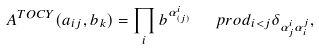<formula> <loc_0><loc_0><loc_500><loc_500>A ^ { T O C Y } ( a _ { i j } , b _ { k } ) = \prod _ { i } b ^ { \alpha ^ { i } _ { ( j ) } } \ \ \ p r o d _ { i < j } \delta _ { \alpha ^ { i } _ { j } \alpha ^ { j } _ { i } } ,</formula> 